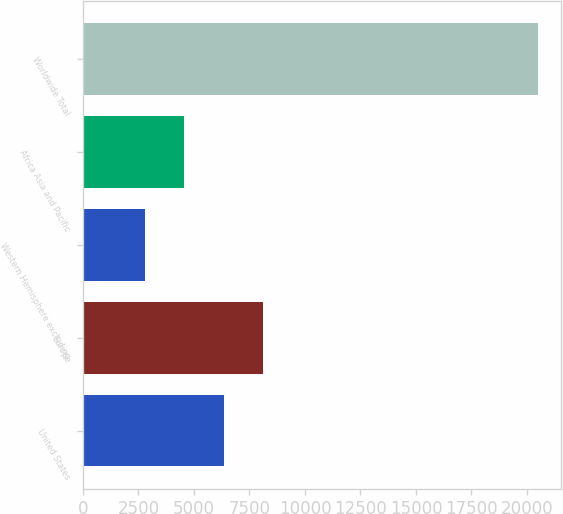Convert chart to OTSL. <chart><loc_0><loc_0><loc_500><loc_500><bar_chart><fcel>United States<fcel>Europe<fcel>Western Hemisphere excluding<fcel>Africa Asia and Pacific<fcel>Worldwide Total<nl><fcel>6341<fcel>8111.5<fcel>2800<fcel>4570.5<fcel>20505<nl></chart> 